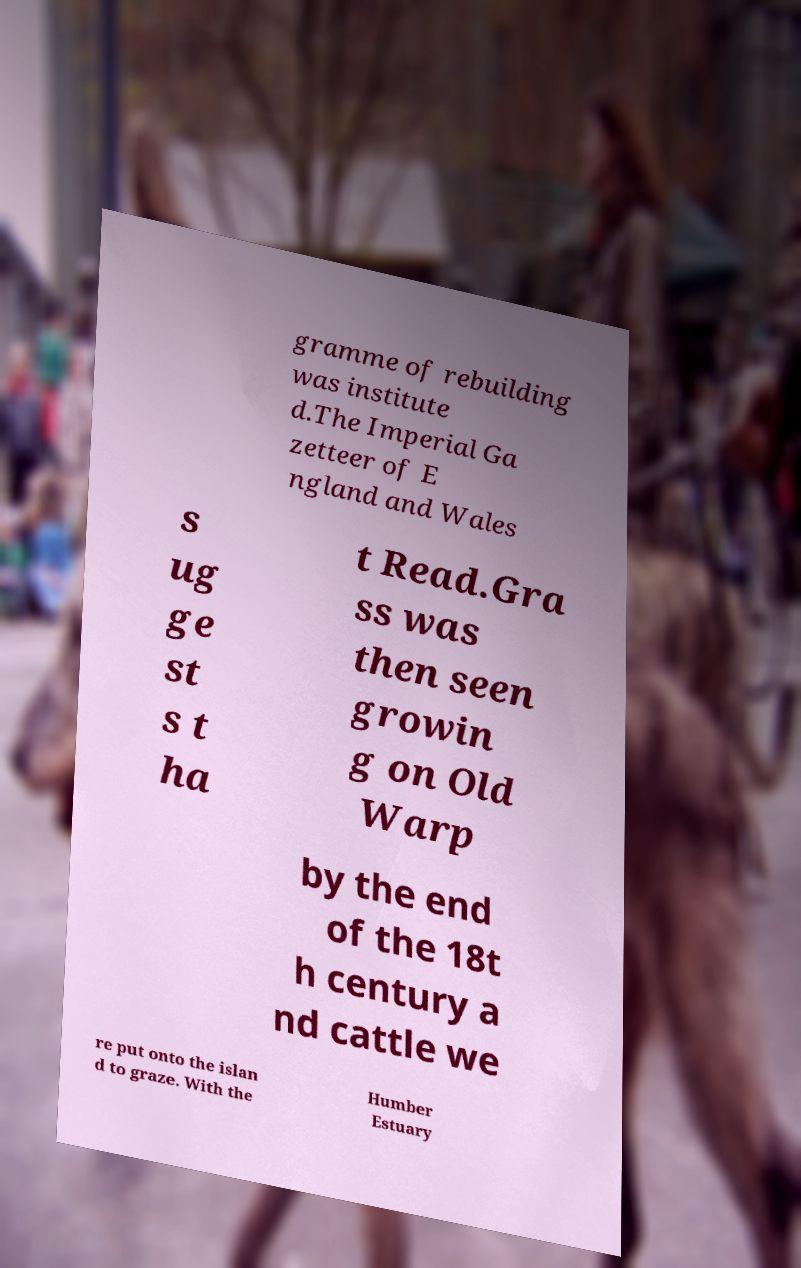For documentation purposes, I need the text within this image transcribed. Could you provide that? gramme of rebuilding was institute d.The Imperial Ga zetteer of E ngland and Wales s ug ge st s t ha t Read.Gra ss was then seen growin g on Old Warp by the end of the 18t h century a nd cattle we re put onto the islan d to graze. With the Humber Estuary 